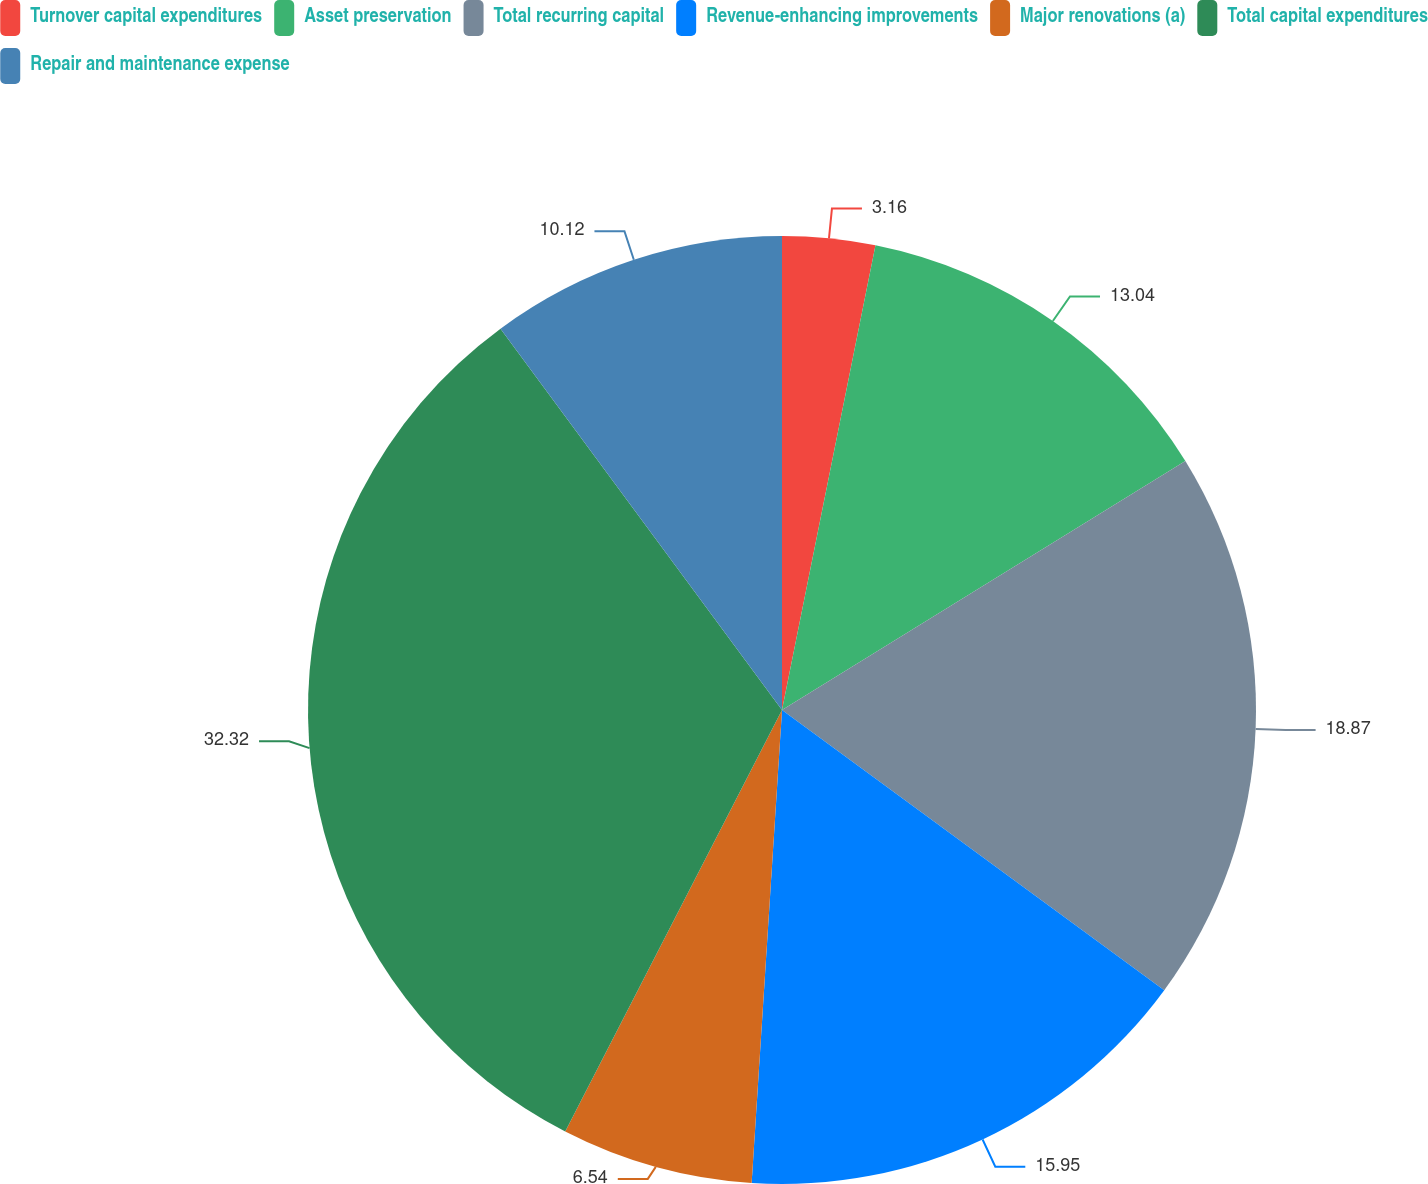Convert chart to OTSL. <chart><loc_0><loc_0><loc_500><loc_500><pie_chart><fcel>Turnover capital expenditures<fcel>Asset preservation<fcel>Total recurring capital<fcel>Revenue-enhancing improvements<fcel>Major renovations (a)<fcel>Total capital expenditures<fcel>Repair and maintenance expense<nl><fcel>3.16%<fcel>13.04%<fcel>18.87%<fcel>15.95%<fcel>6.54%<fcel>32.32%<fcel>10.12%<nl></chart> 